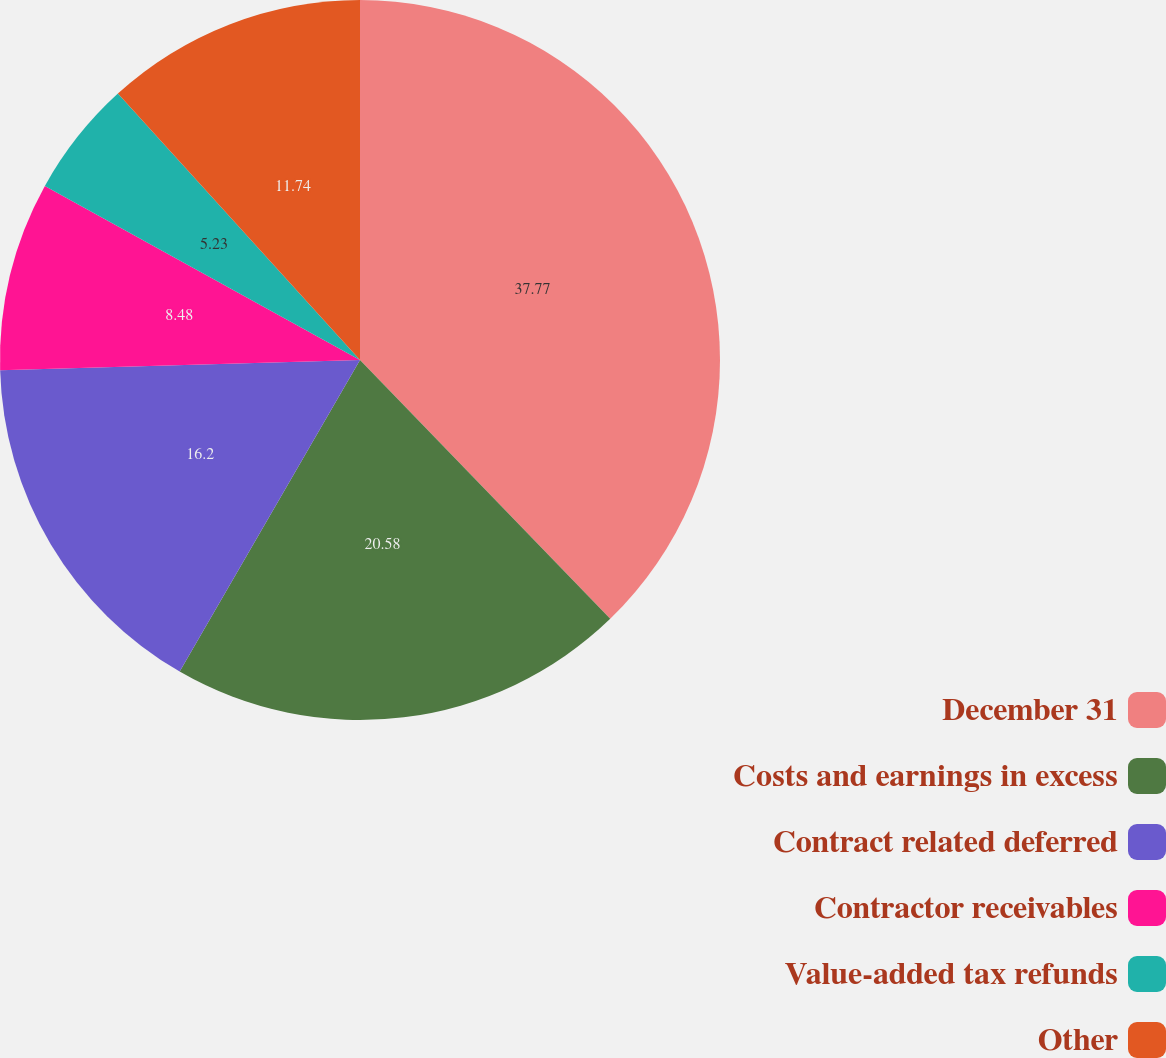<chart> <loc_0><loc_0><loc_500><loc_500><pie_chart><fcel>December 31<fcel>Costs and earnings in excess<fcel>Contract related deferred<fcel>Contractor receivables<fcel>Value-added tax refunds<fcel>Other<nl><fcel>37.77%<fcel>20.58%<fcel>16.2%<fcel>8.48%<fcel>5.23%<fcel>11.74%<nl></chart> 